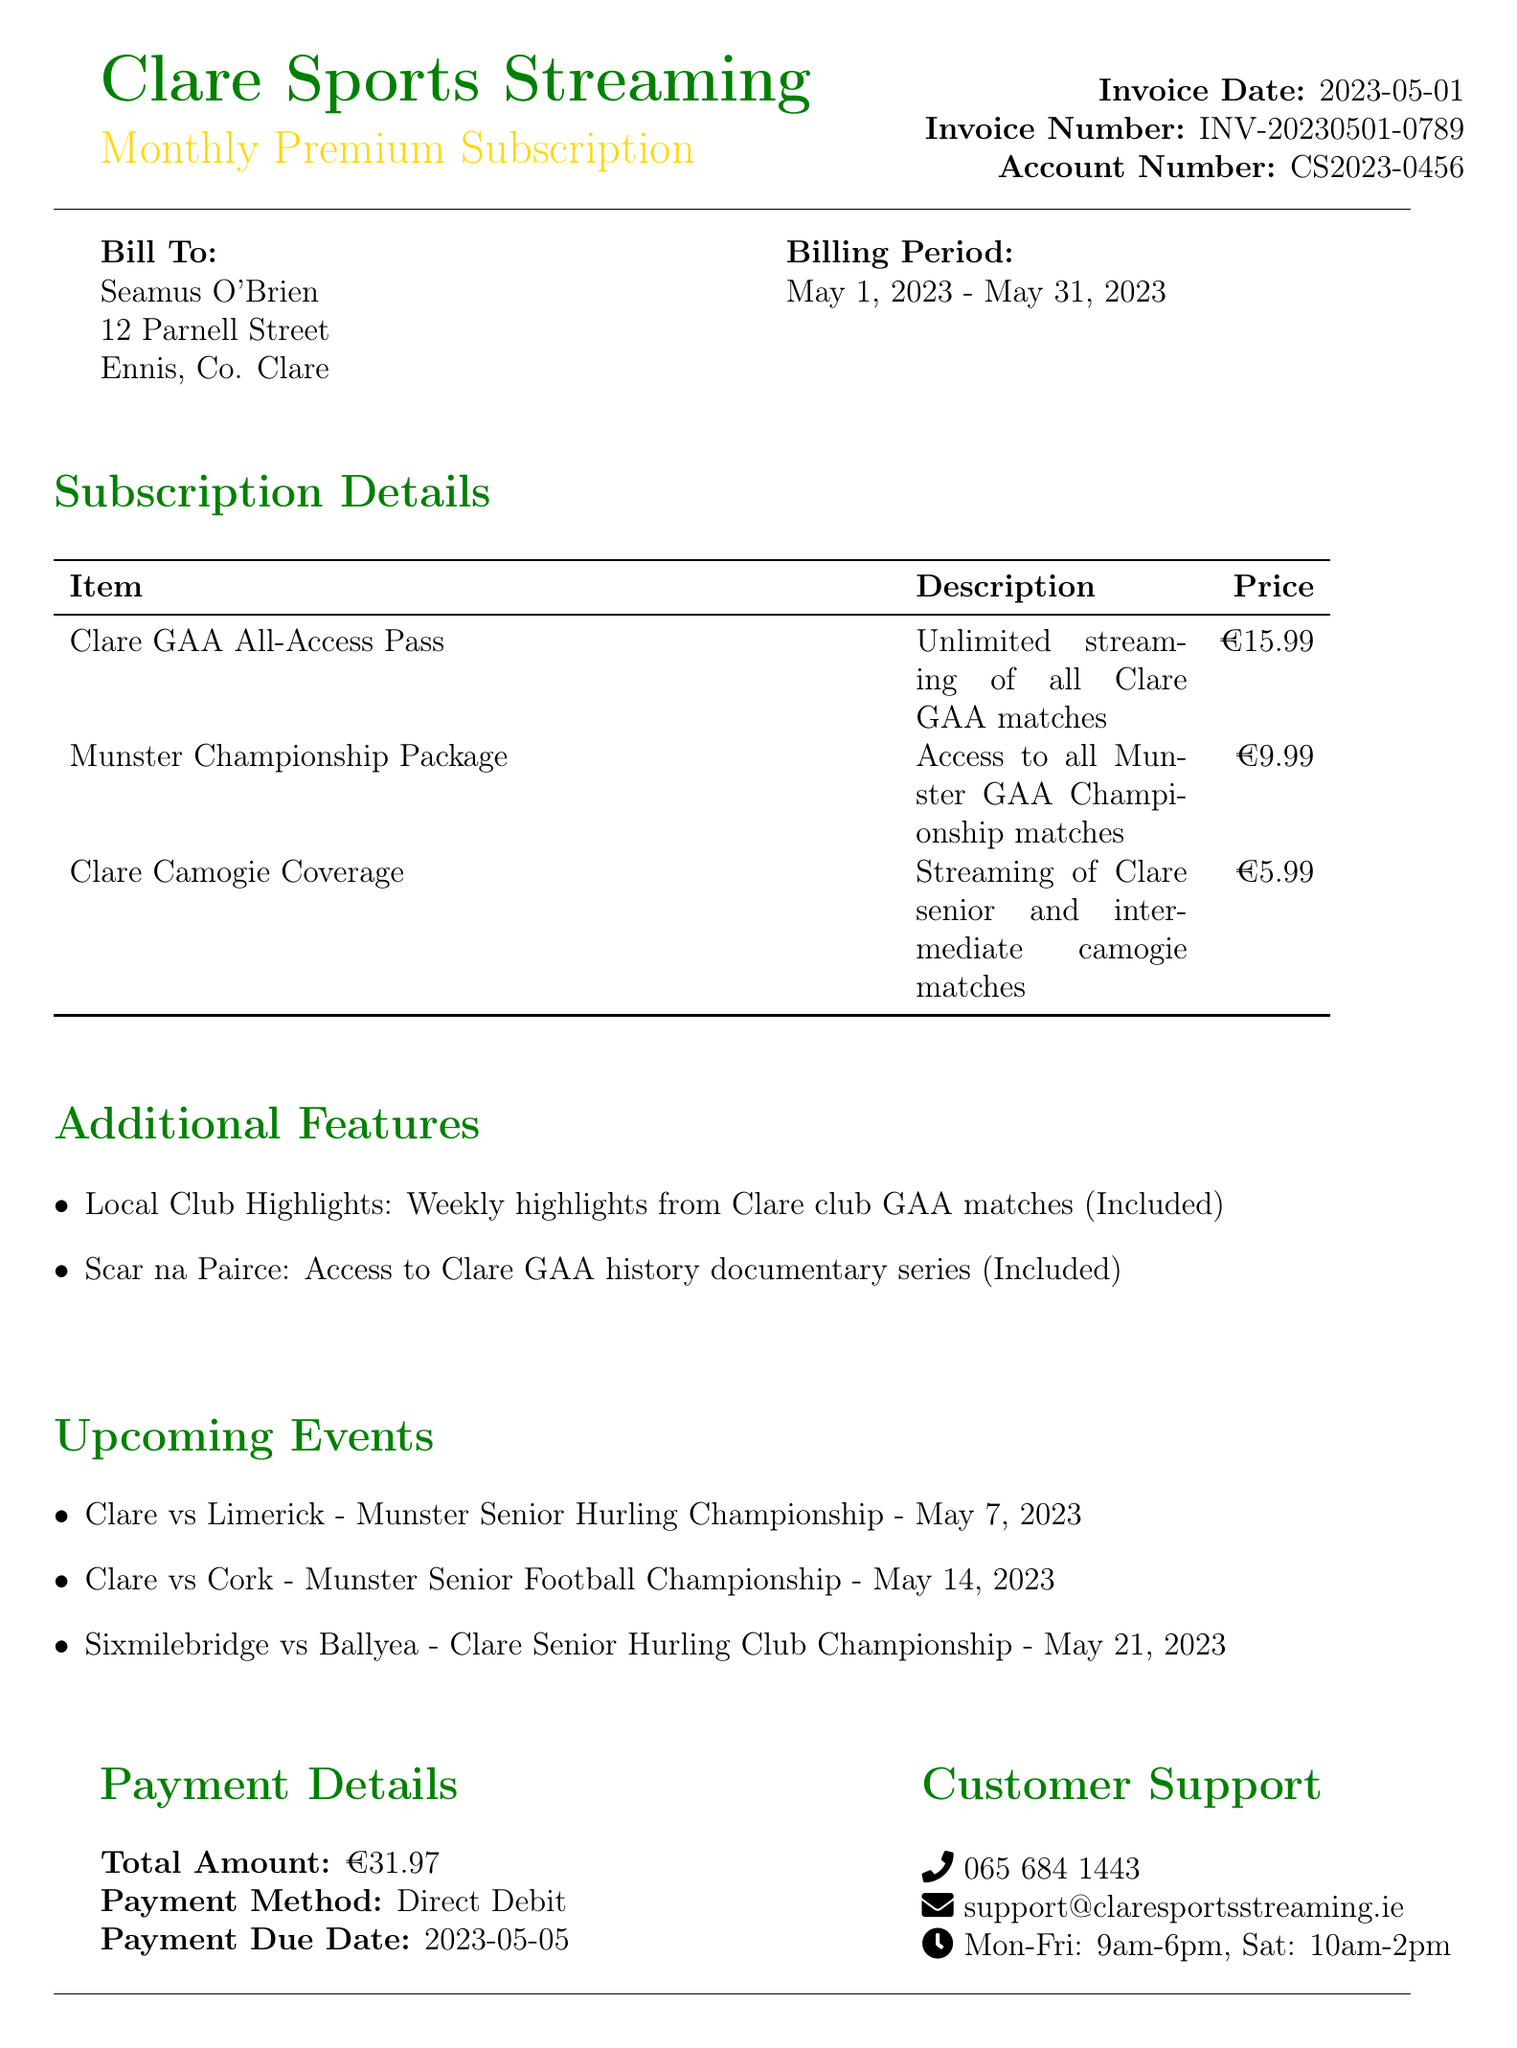What is the service name? The service name is mentioned at the beginning of the document as Clare Sports Streaming.
Answer: Clare Sports Streaming When is the payment due? The payment due date is specified in the payment details section.
Answer: 2023-05-05 Who is the customer? The customer name is stated in the billing information section.
Answer: Seamus O'Brien What is included in the Munster Championship Package? The description provides details about what is included in the package.
Answer: Access to all Munster GAA Championship matches What is the total amount for this invoice? The total amount is stated clearly in the payment details section.
Answer: €31.97 Which document number is associated with this invoice? The invoice number is listed in the header of the document.
Answer: INV-20230501-0789 What is the cultural event featured this month? The document contains a cultural note that highlights the event.
Answer: Fleadh Nua 2023 What is the phone number for customer support? The customer support section lists the phone number for inquiries.
Answer: 065 684 1443 What special offer is mentioned in the document? The special offer is outlined towards the end of the document.
Answer: Refer a friend and get 50% off next month's subscription 